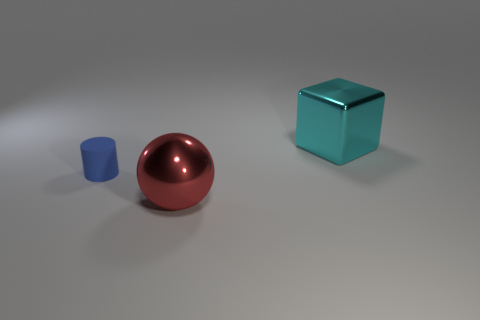Add 3 cubes. How many objects exist? 6 Subtract all cubes. How many objects are left? 2 Subtract all tiny gray shiny cylinders. Subtract all large shiny blocks. How many objects are left? 2 Add 3 cyan metallic objects. How many cyan metallic objects are left? 4 Add 1 large red objects. How many large red objects exist? 2 Subtract 0 brown spheres. How many objects are left? 3 Subtract all red cylinders. Subtract all blue balls. How many cylinders are left? 1 Subtract all cyan cubes. How many purple cylinders are left? 0 